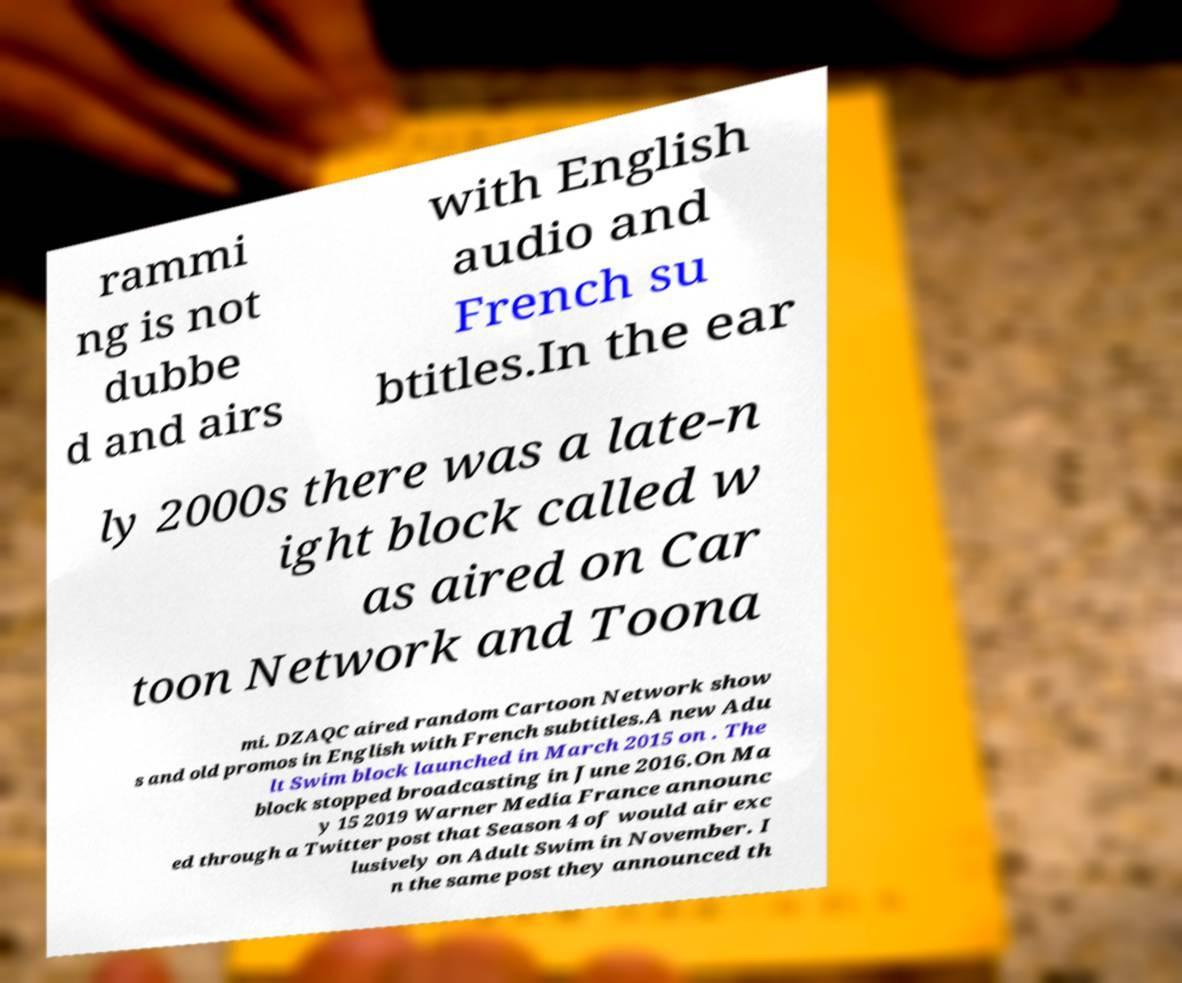Can you accurately transcribe the text from the provided image for me? rammi ng is not dubbe d and airs with English audio and French su btitles.In the ear ly 2000s there was a late-n ight block called w as aired on Car toon Network and Toona mi. DZAQC aired random Cartoon Network show s and old promos in English with French subtitles.A new Adu lt Swim block launched in March 2015 on . The block stopped broadcasting in June 2016.On Ma y 15 2019 Warner Media France announc ed through a Twitter post that Season 4 of would air exc lusively on Adult Swim in November. I n the same post they announced th 